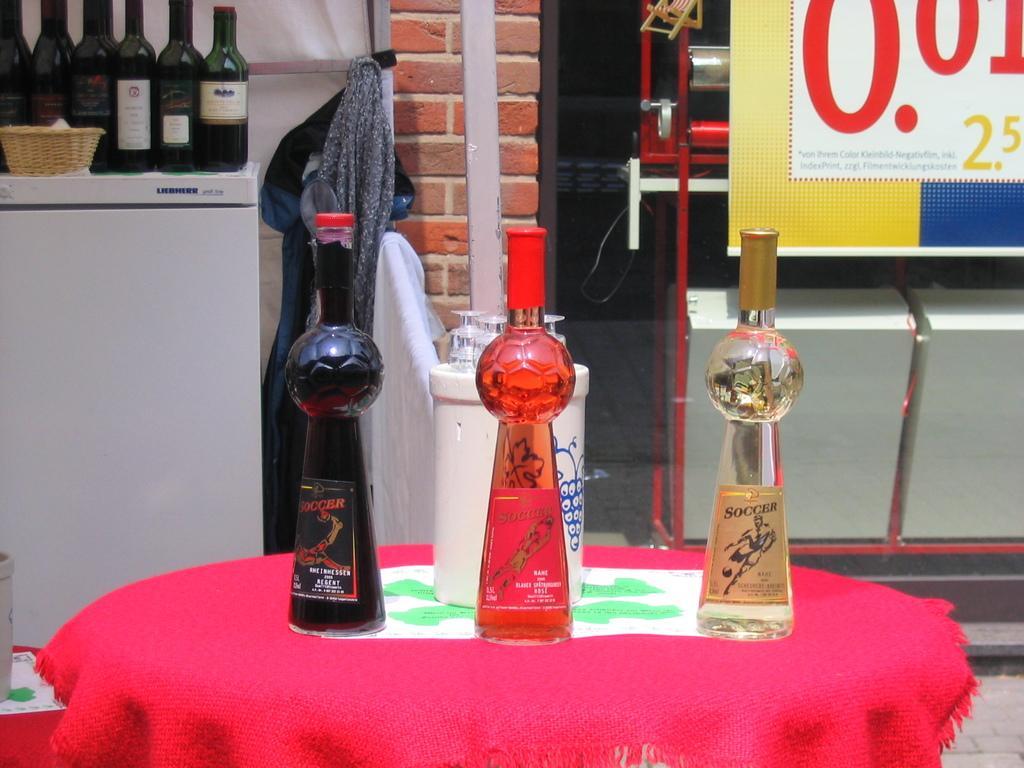Please provide a concise description of this image. In this picture there are few bottles on the refrigerator. There is a basket. There is a cloth. There are some objects and glasses on the table. There is a red cloth. 